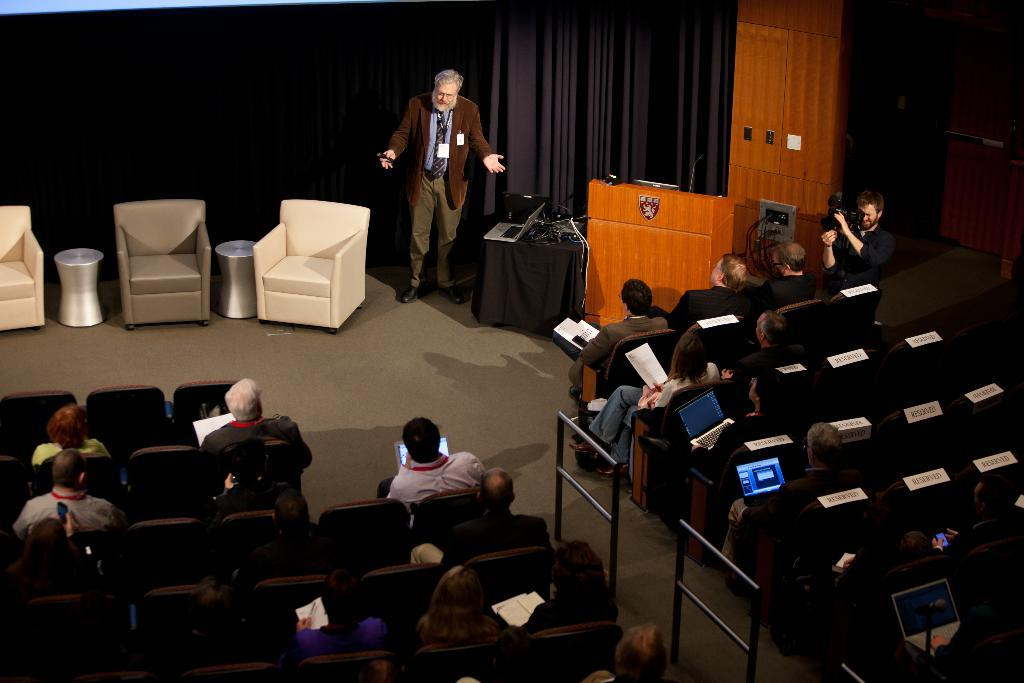What type of furniture is in the image? There is a chair in the image. What electronic device is visible in the image? There is a laptop in the image. What can be seen on the table in the image? Cables are present on the table. What structure is in the image that might be used for presentations? There is a podium in the image. Who is near the table in the image? There is a man standing near the table. What are the people in the image doing? There is a group of people sitting in chairs. What signage is visible in the image? Name boards are visible in the image. What device is used for capturing images in the image? A camera is present in the image. What type of fruit is being sold in the store in the image? There is no store or fruit present in the image. How many quince are visible on the podium in the image? There are no quince present in the image. 